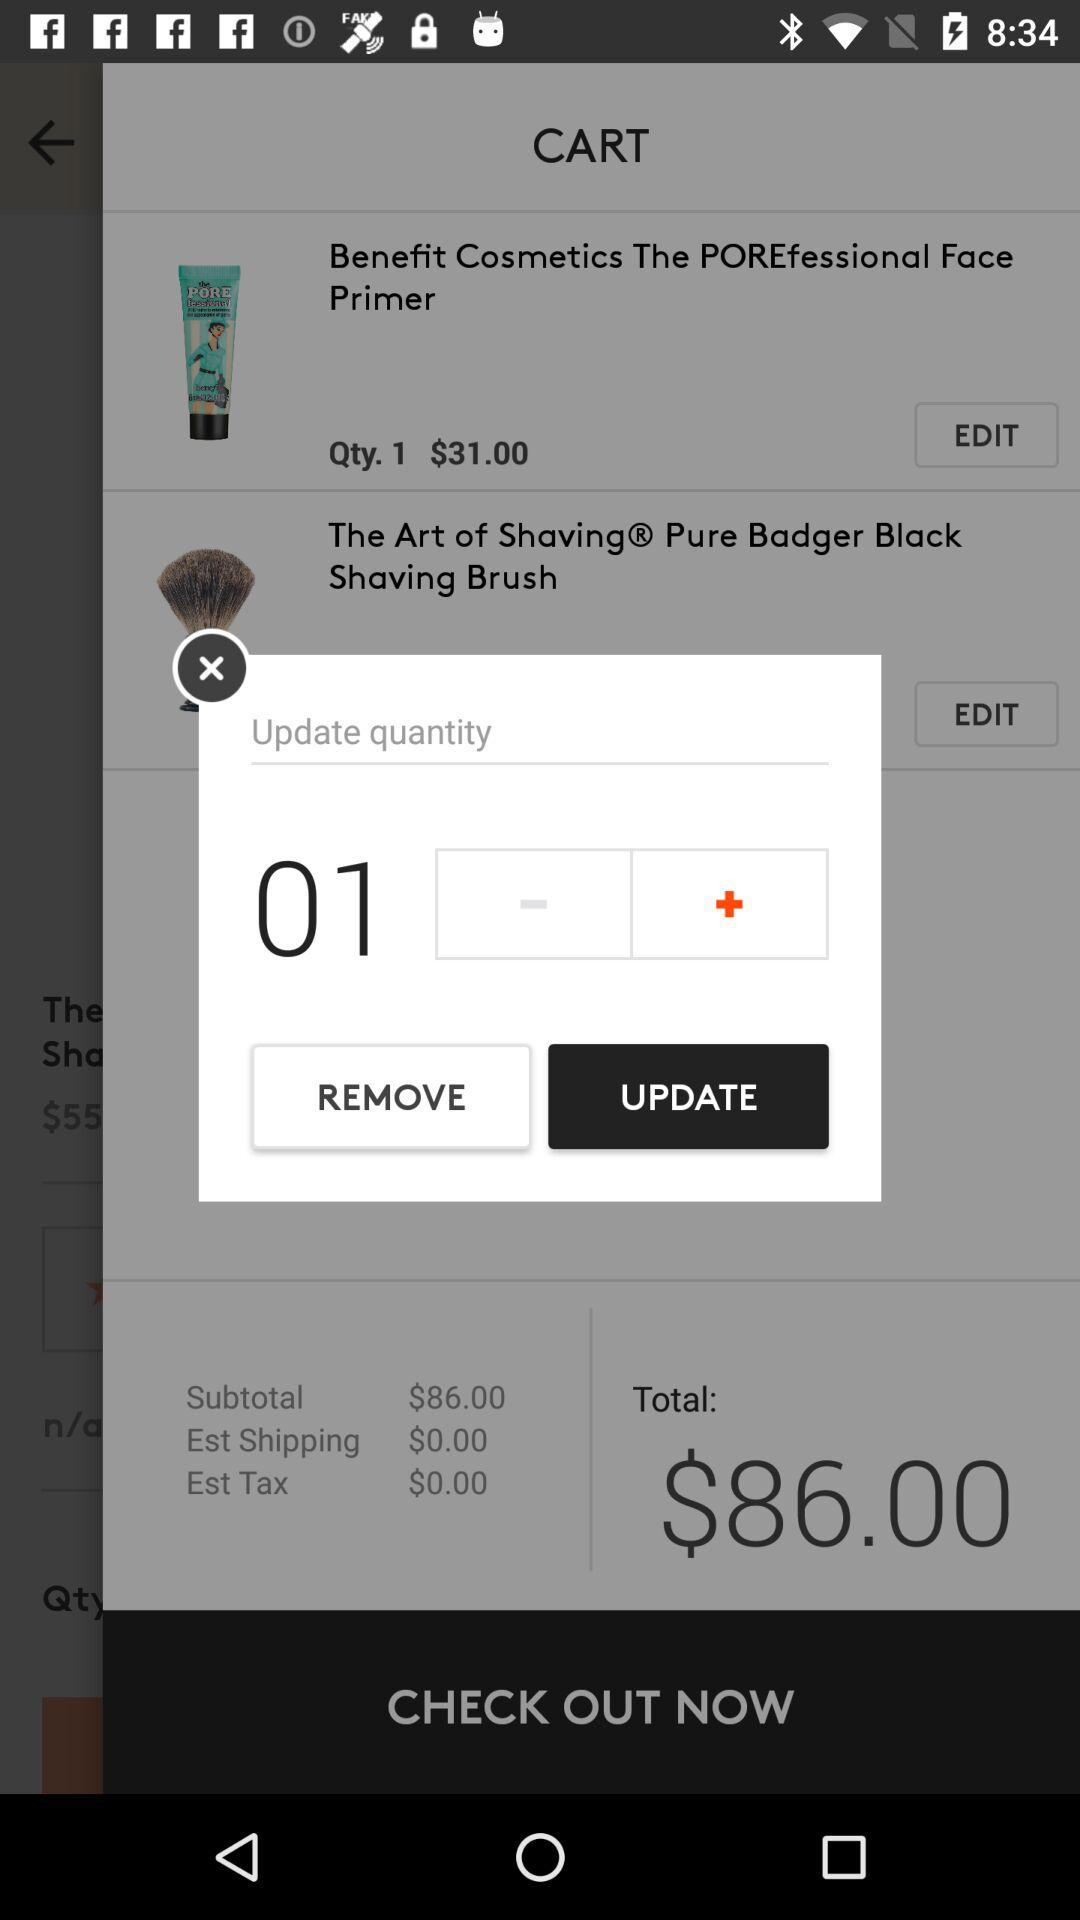How many products are in the cart?
Answer the question using a single word or phrase. 2 